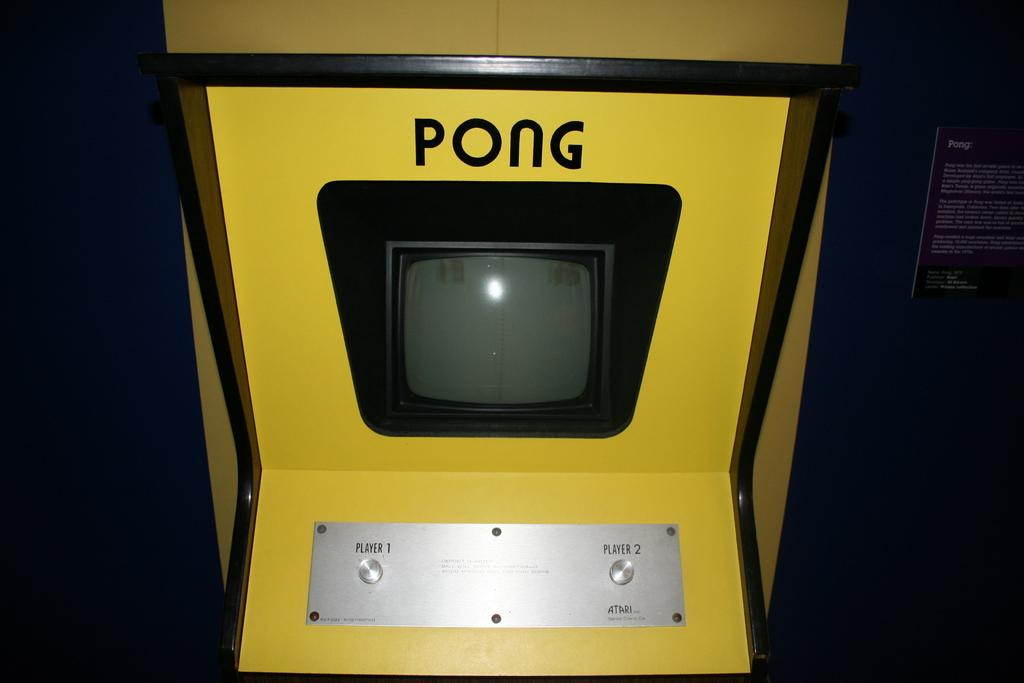What is the main object in the center of the image? There is a yellow color pong cabinet in the center of the image. What can be seen in the background of the image? There is a poster attached to the wall in the background. What is written or depicted on the poster? Text is visible on the poster. How does the coast affect the game of ping pong in the image? There is no coast present in the image, so it does not affect the game of ping pong. What type of cup is being used to blow air on the ping pong ball in the image? There is no cup or blowing of air on the ping pong ball in the image. 